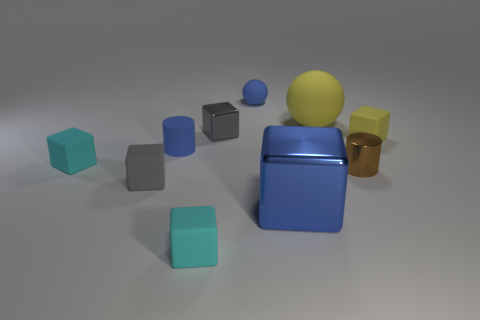Which object in the image appears to be closest to the light source? The closest object to the light source appears to be the large blue glossy cube in the center. This is suggested by the brighter highlight on its top surface and slightly shorter shadow compared to the other objects. 